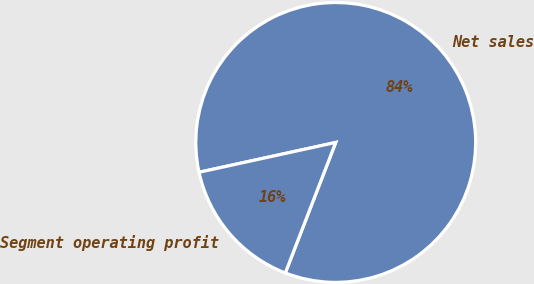Convert chart. <chart><loc_0><loc_0><loc_500><loc_500><pie_chart><fcel>Net sales<fcel>Segment operating profit<nl><fcel>84.29%<fcel>15.71%<nl></chart> 